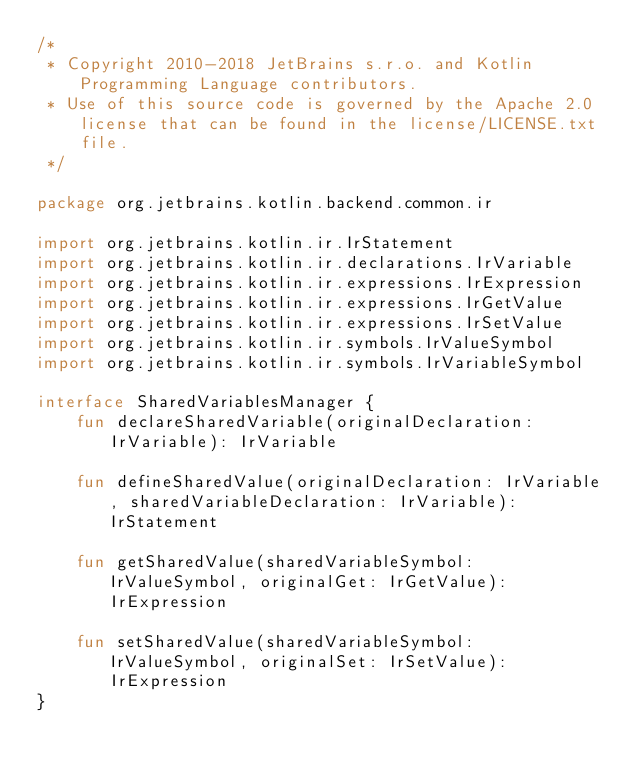<code> <loc_0><loc_0><loc_500><loc_500><_Kotlin_>/*
 * Copyright 2010-2018 JetBrains s.r.o. and Kotlin Programming Language contributors.
 * Use of this source code is governed by the Apache 2.0 license that can be found in the license/LICENSE.txt file.
 */

package org.jetbrains.kotlin.backend.common.ir

import org.jetbrains.kotlin.ir.IrStatement
import org.jetbrains.kotlin.ir.declarations.IrVariable
import org.jetbrains.kotlin.ir.expressions.IrExpression
import org.jetbrains.kotlin.ir.expressions.IrGetValue
import org.jetbrains.kotlin.ir.expressions.IrSetValue
import org.jetbrains.kotlin.ir.symbols.IrValueSymbol
import org.jetbrains.kotlin.ir.symbols.IrVariableSymbol

interface SharedVariablesManager {
    fun declareSharedVariable(originalDeclaration: IrVariable): IrVariable

    fun defineSharedValue(originalDeclaration: IrVariable, sharedVariableDeclaration: IrVariable): IrStatement

    fun getSharedValue(sharedVariableSymbol: IrValueSymbol, originalGet: IrGetValue): IrExpression

    fun setSharedValue(sharedVariableSymbol: IrValueSymbol, originalSet: IrSetValue): IrExpression
}</code> 